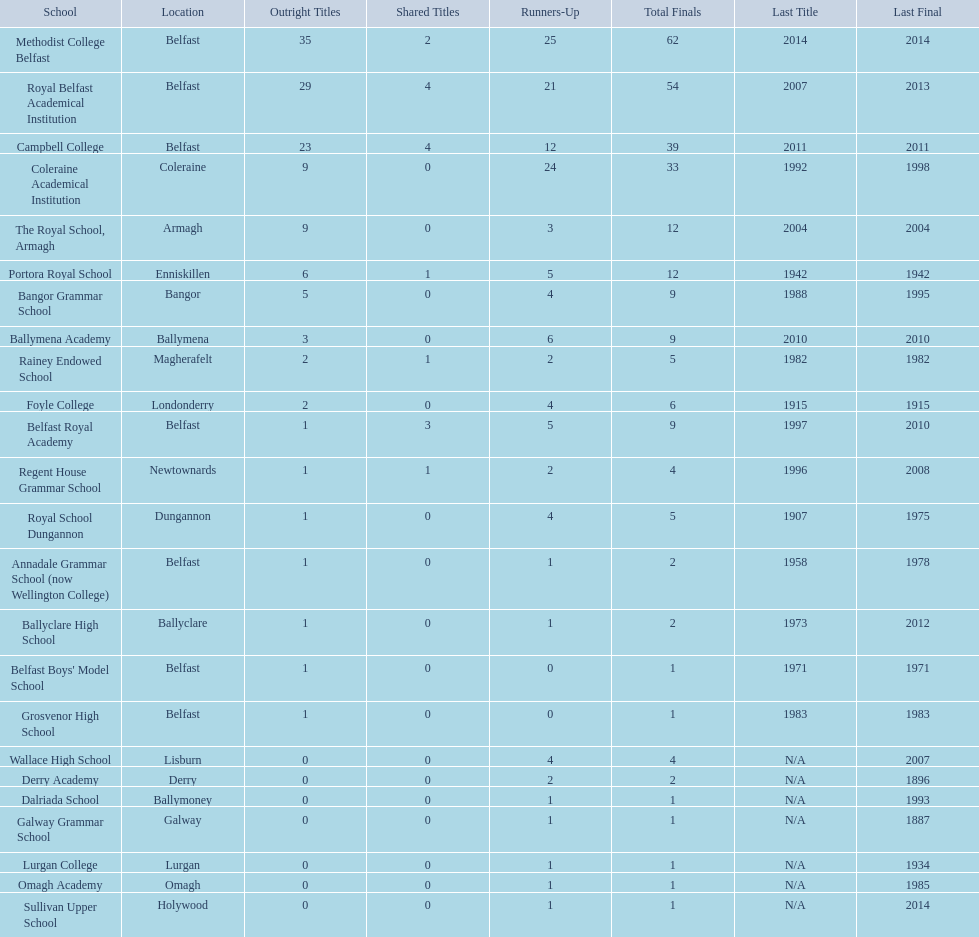Which academic institutions participated in the ulster schools' cup? Methodist College Belfast, Royal Belfast Academical Institution, Campbell College, Coleraine Academical Institution, The Royal School, Armagh, Portora Royal School, Bangor Grammar School, Ballymena Academy, Rainey Endowed School, Foyle College, Belfast Royal Academy, Regent House Grammar School, Royal School Dungannon, Annadale Grammar School (now Wellington College), Ballyclare High School, Belfast Boys' Model School, Grosvenor High School, Wallace High School, Derry Academy, Dalriada School, Galway Grammar School, Lurgan College, Omagh Academy, Sullivan Upper School. Of these, which ones are situated in belfast? Methodist College Belfast, Royal Belfast Academical Institution, Campbell College, Belfast Royal Academy, Annadale Grammar School (now Wellington College), Belfast Boys' Model School, Grosvenor High School. Of those, which have surpassed 20 outright title wins? Methodist College Belfast, Royal Belfast Academical Institution, Campbell College. Which of them have the minimum number of second-place positions? Campbell College. 